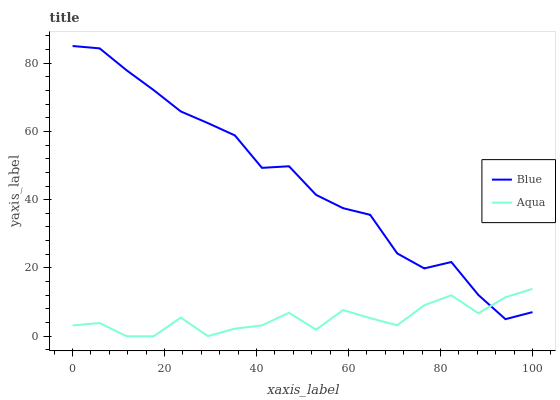Does Aqua have the minimum area under the curve?
Answer yes or no. Yes. Does Blue have the maximum area under the curve?
Answer yes or no. Yes. Does Aqua have the maximum area under the curve?
Answer yes or no. No. Is Blue the smoothest?
Answer yes or no. Yes. Is Aqua the roughest?
Answer yes or no. Yes. Is Aqua the smoothest?
Answer yes or no. No. Does Aqua have the lowest value?
Answer yes or no. Yes. Does Blue have the highest value?
Answer yes or no. Yes. Does Aqua have the highest value?
Answer yes or no. No. Does Blue intersect Aqua?
Answer yes or no. Yes. Is Blue less than Aqua?
Answer yes or no. No. Is Blue greater than Aqua?
Answer yes or no. No. 